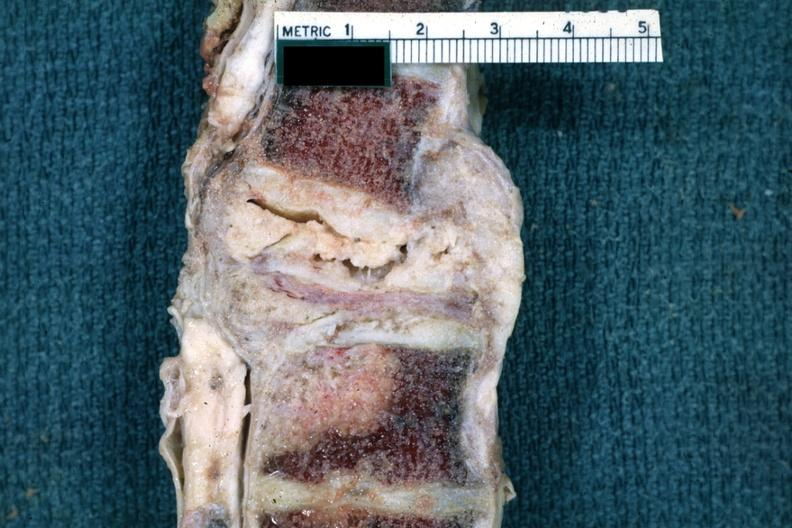s tuberculous peritonitis present?
Answer the question using a single word or phrase. No 